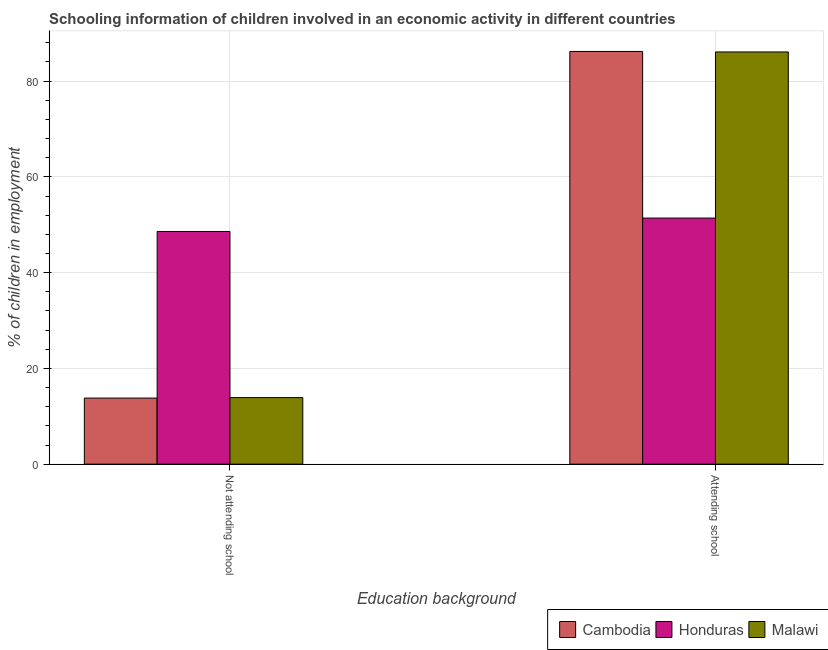How many groups of bars are there?
Your answer should be compact. 2. How many bars are there on the 1st tick from the right?
Ensure brevity in your answer.  3. What is the label of the 1st group of bars from the left?
Keep it short and to the point. Not attending school. What is the percentage of employed children who are not attending school in Honduras?
Provide a succinct answer. 48.6. Across all countries, what is the maximum percentage of employed children who are attending school?
Keep it short and to the point. 86.2. Across all countries, what is the minimum percentage of employed children who are attending school?
Offer a terse response. 51.4. In which country was the percentage of employed children who are attending school maximum?
Your answer should be very brief. Cambodia. In which country was the percentage of employed children who are attending school minimum?
Offer a very short reply. Honduras. What is the total percentage of employed children who are not attending school in the graph?
Keep it short and to the point. 76.3. What is the difference between the percentage of employed children who are not attending school in Cambodia and that in Honduras?
Provide a short and direct response. -34.8. What is the difference between the percentage of employed children who are attending school in Honduras and the percentage of employed children who are not attending school in Cambodia?
Offer a very short reply. 37.6. What is the average percentage of employed children who are not attending school per country?
Your answer should be compact. 25.43. What is the difference between the percentage of employed children who are attending school and percentage of employed children who are not attending school in Honduras?
Offer a terse response. 2.8. In how many countries, is the percentage of employed children who are attending school greater than 76 %?
Give a very brief answer. 2. What is the ratio of the percentage of employed children who are attending school in Cambodia to that in Honduras?
Your response must be concise. 1.68. Is the percentage of employed children who are not attending school in Malawi less than that in Cambodia?
Provide a succinct answer. No. In how many countries, is the percentage of employed children who are attending school greater than the average percentage of employed children who are attending school taken over all countries?
Keep it short and to the point. 2. What does the 3rd bar from the left in Not attending school represents?
Provide a succinct answer. Malawi. What does the 3rd bar from the right in Attending school represents?
Provide a succinct answer. Cambodia. Are all the bars in the graph horizontal?
Make the answer very short. No. How many countries are there in the graph?
Offer a very short reply. 3. What is the difference between two consecutive major ticks on the Y-axis?
Provide a succinct answer. 20. Are the values on the major ticks of Y-axis written in scientific E-notation?
Provide a short and direct response. No. Does the graph contain any zero values?
Provide a succinct answer. No. Where does the legend appear in the graph?
Your response must be concise. Bottom right. How are the legend labels stacked?
Provide a short and direct response. Horizontal. What is the title of the graph?
Make the answer very short. Schooling information of children involved in an economic activity in different countries. What is the label or title of the X-axis?
Give a very brief answer. Education background. What is the label or title of the Y-axis?
Offer a terse response. % of children in employment. What is the % of children in employment of Honduras in Not attending school?
Your answer should be very brief. 48.6. What is the % of children in employment of Malawi in Not attending school?
Your answer should be compact. 13.9. What is the % of children in employment in Cambodia in Attending school?
Offer a very short reply. 86.2. What is the % of children in employment in Honduras in Attending school?
Your answer should be compact. 51.4. What is the % of children in employment in Malawi in Attending school?
Provide a succinct answer. 86.1. Across all Education background, what is the maximum % of children in employment of Cambodia?
Give a very brief answer. 86.2. Across all Education background, what is the maximum % of children in employment in Honduras?
Make the answer very short. 51.4. Across all Education background, what is the maximum % of children in employment of Malawi?
Offer a terse response. 86.1. Across all Education background, what is the minimum % of children in employment in Honduras?
Give a very brief answer. 48.6. What is the total % of children in employment of Honduras in the graph?
Make the answer very short. 100. What is the difference between the % of children in employment of Cambodia in Not attending school and that in Attending school?
Offer a terse response. -72.4. What is the difference between the % of children in employment in Malawi in Not attending school and that in Attending school?
Your response must be concise. -72.2. What is the difference between the % of children in employment of Cambodia in Not attending school and the % of children in employment of Honduras in Attending school?
Provide a succinct answer. -37.6. What is the difference between the % of children in employment of Cambodia in Not attending school and the % of children in employment of Malawi in Attending school?
Give a very brief answer. -72.3. What is the difference between the % of children in employment of Honduras in Not attending school and the % of children in employment of Malawi in Attending school?
Provide a short and direct response. -37.5. What is the difference between the % of children in employment in Cambodia and % of children in employment in Honduras in Not attending school?
Provide a short and direct response. -34.8. What is the difference between the % of children in employment of Cambodia and % of children in employment of Malawi in Not attending school?
Offer a very short reply. -0.1. What is the difference between the % of children in employment in Honduras and % of children in employment in Malawi in Not attending school?
Provide a short and direct response. 34.7. What is the difference between the % of children in employment in Cambodia and % of children in employment in Honduras in Attending school?
Provide a succinct answer. 34.8. What is the difference between the % of children in employment in Honduras and % of children in employment in Malawi in Attending school?
Your response must be concise. -34.7. What is the ratio of the % of children in employment of Cambodia in Not attending school to that in Attending school?
Ensure brevity in your answer.  0.16. What is the ratio of the % of children in employment in Honduras in Not attending school to that in Attending school?
Your answer should be compact. 0.95. What is the ratio of the % of children in employment in Malawi in Not attending school to that in Attending school?
Offer a terse response. 0.16. What is the difference between the highest and the second highest % of children in employment of Cambodia?
Give a very brief answer. 72.4. What is the difference between the highest and the second highest % of children in employment in Honduras?
Offer a very short reply. 2.8. What is the difference between the highest and the second highest % of children in employment in Malawi?
Give a very brief answer. 72.2. What is the difference between the highest and the lowest % of children in employment in Cambodia?
Provide a succinct answer. 72.4. What is the difference between the highest and the lowest % of children in employment of Honduras?
Offer a very short reply. 2.8. What is the difference between the highest and the lowest % of children in employment in Malawi?
Provide a succinct answer. 72.2. 